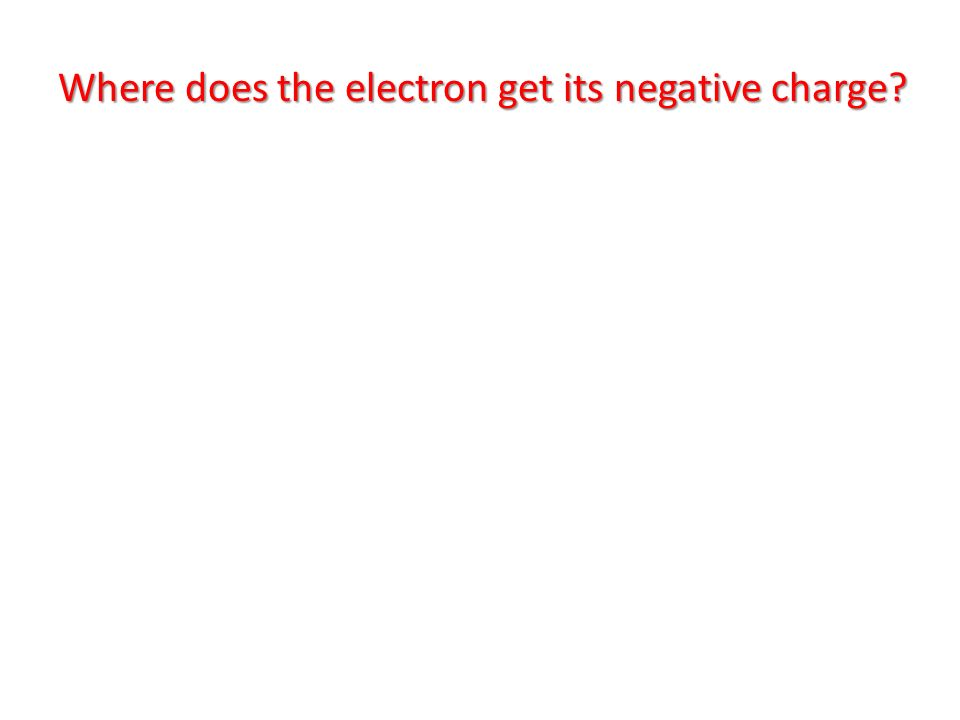What are the scientific reasons behind the electron's negative charge, and how does this concept interact with the visual representation of urgency in the question? Electrons possess a negative charge due to the fundamental properties of subatomic particles. This charge is an intrinsic attribute of electrons, defined by the electromagnetic force in physics. The concept of an electron's negative charge is rooted in the nature of elementary particles and quantum mechanics. In visual representations, combining the scientific concept of negative charge with urgent colors, such as red, can create a compelling emphasis on the importance of understanding such fundamental aspects of physics. Red captures attention and drives home the critical nature of the question, emphasizing its importance in educational and scientific contexts. Can you elaborate on the role of electrons in the broader context of atomic structure and chemical interactions? Electrons play a crucial role in atomic structure and chemical interactions. Within an atom, electrons orbit the nucleus, which contains positively charged protons and neutral neutrons. The negative charge of electrons balances the positive charge of protons, creating a stable atom. The arrangement of electrons in various energy levels or shells determines how atoms interact and bond with each other. Electrons in the outermost shell, called valence electrons, are primarily responsible for chemical reactions. They can be shared, donated, or received during chemical bonding, leading to the formation of molecules and compounds. Understanding the behavior of electrons is essential for comprehending chemical properties and reactions, as well as the formation of different materials and substances in nature. 